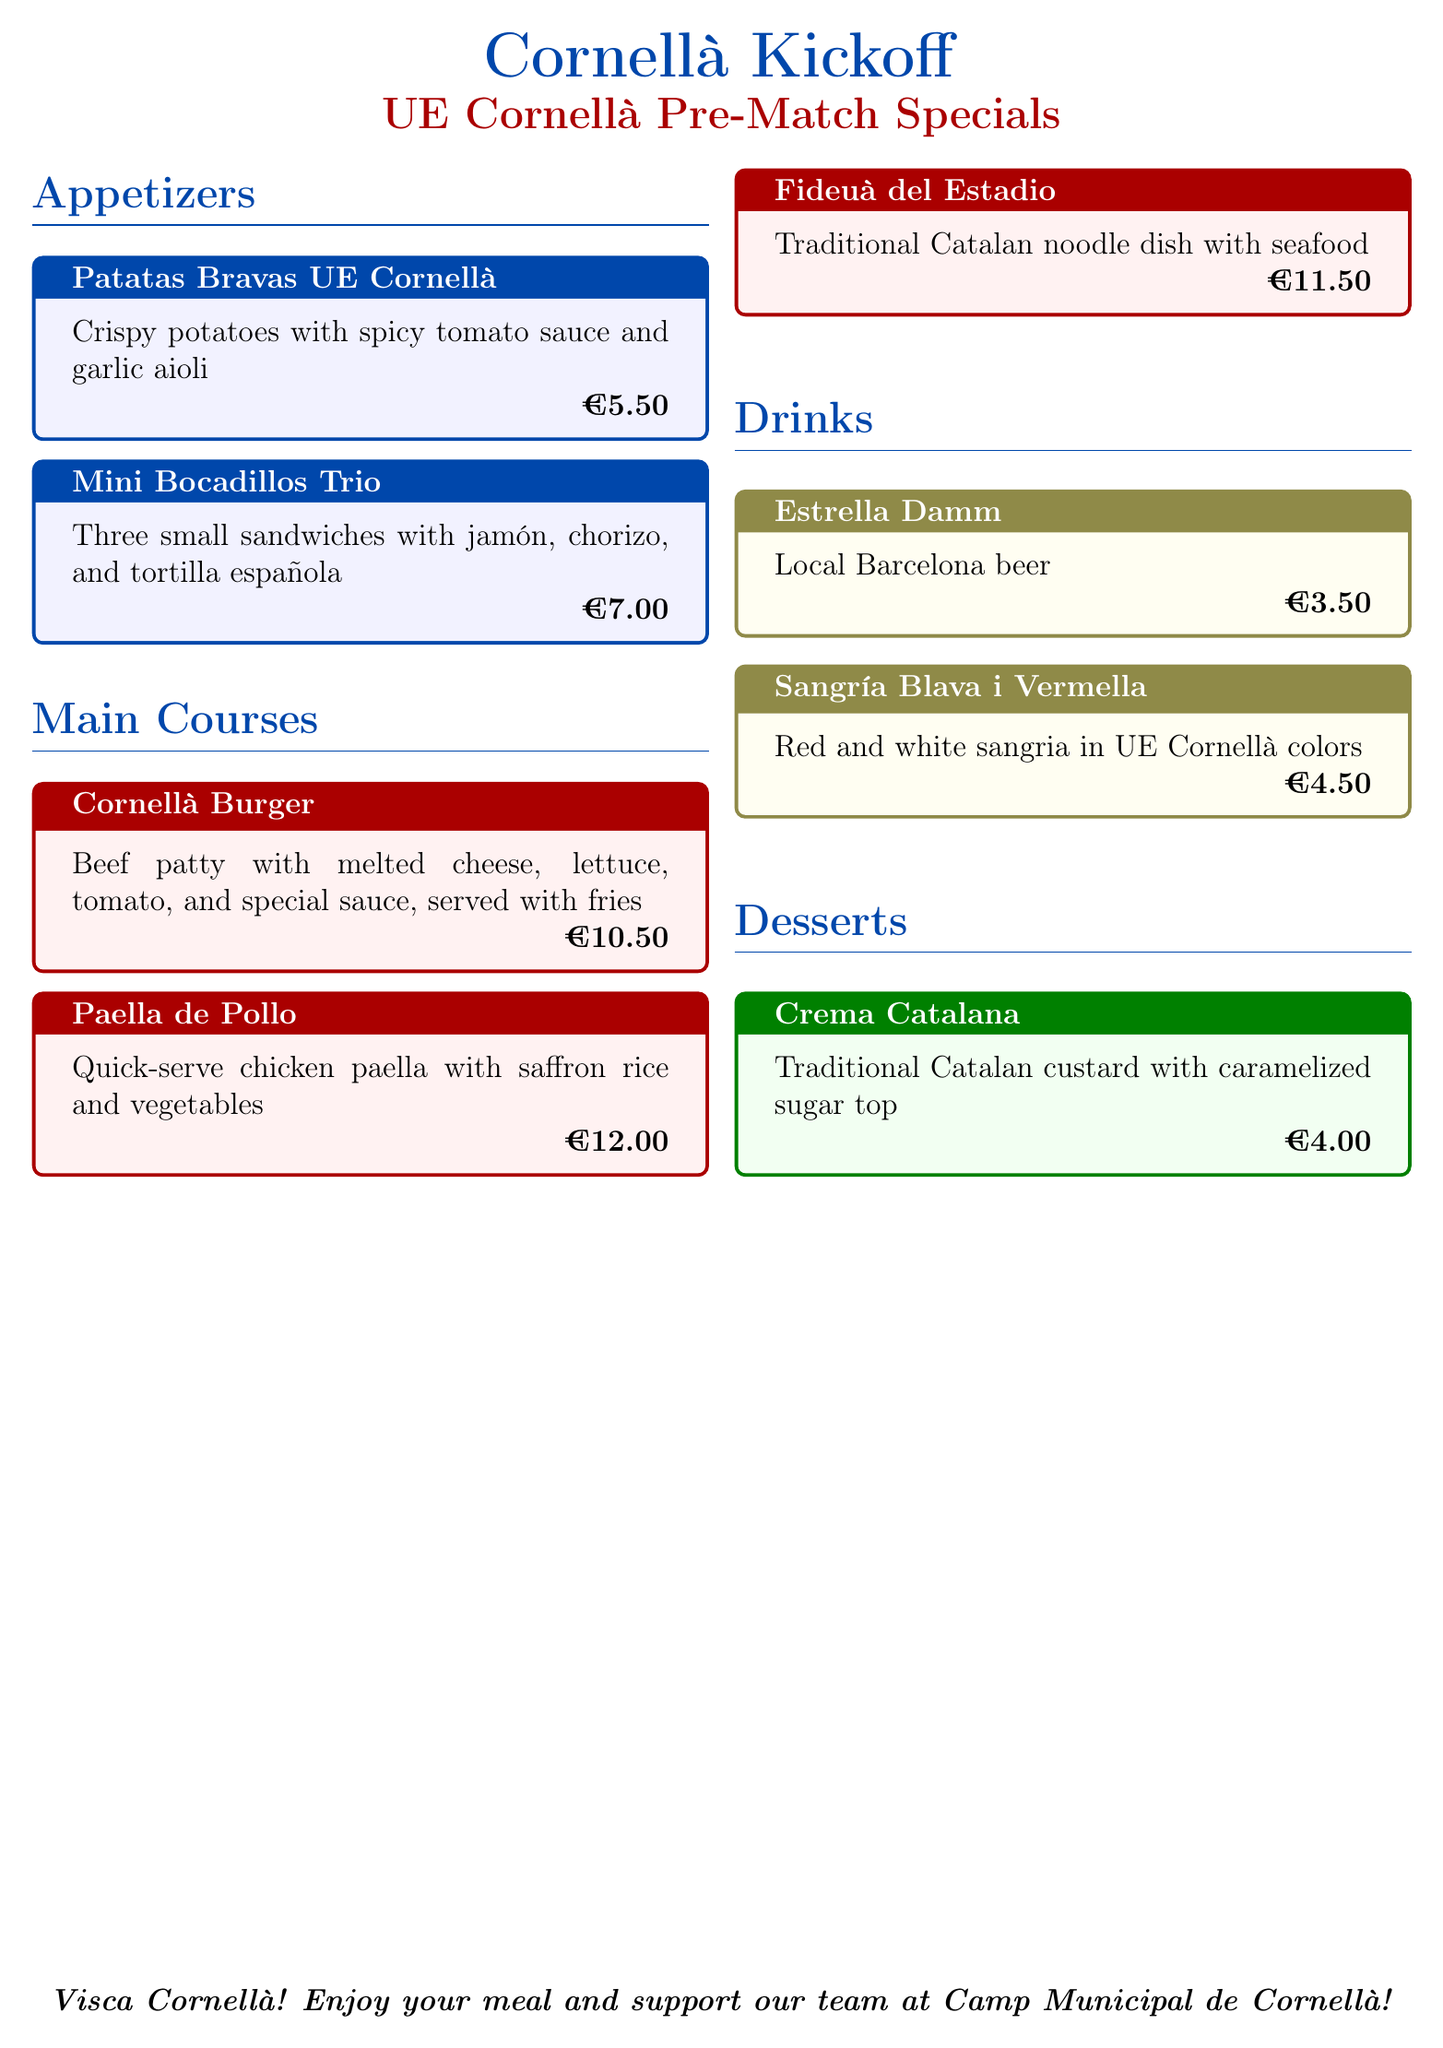what is the price of Patatas Bravas UE Cornellà? The price listed for Patatas Bravas UE Cornellà is €5.50.
Answer: €5.50 how many mini bocadillos are included in the trio? The menu states that there are three mini bocadillos in the trio.
Answer: three what is the main ingredient of the Cornellà Burger? The Cornellà Burger contains a beef patty as its main ingredient.
Answer: beef patty what type of drink is Sangría Blava i Vermella? Sangría Blava i Vermella is a combination of red and white sangria.
Answer: red and white sangria what dessert is offered in traditional Catalan style? The dessert offered in traditional Catalan style is Crema Catalana.
Answer: Crema Catalana what is unique about Sangría Blava i Vermella? Sangría Blava i Vermella is presented in UE Cornellà colors.
Answer: UE Cornellà colors how much does Fideuà del Estadio cost? The menu lists the price of Fideuà del Estadio as €11.50.
Answer: €11.50 which drink has the lowest price? The drink with the lowest price is Estrella Damm.
Answer: Estrella Damm what is the special sauce on the Cornellà Burger? The specific type of special sauce is not detailed in the document.
Answer: special sauce 